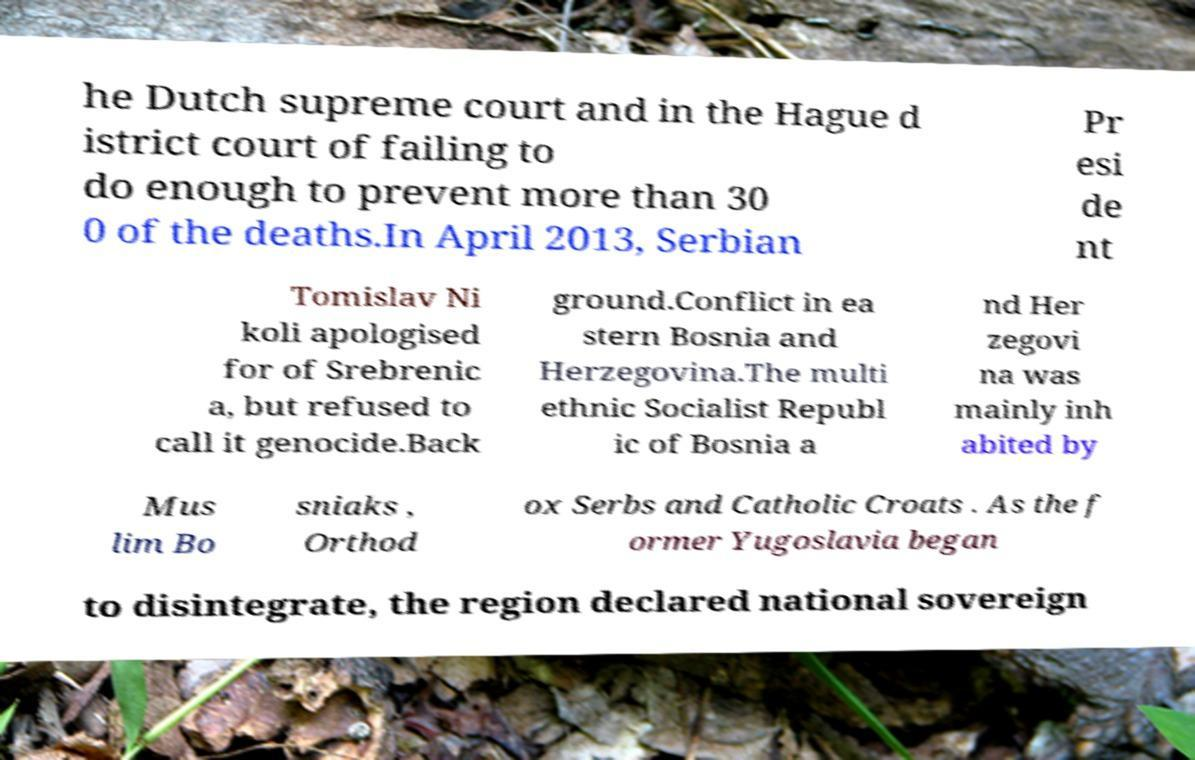Can you read and provide the text displayed in the image?This photo seems to have some interesting text. Can you extract and type it out for me? he Dutch supreme court and in the Hague d istrict court of failing to do enough to prevent more than 30 0 of the deaths.In April 2013, Serbian Pr esi de nt Tomislav Ni koli apologised for of Srebrenic a, but refused to call it genocide.Back ground.Conflict in ea stern Bosnia and Herzegovina.The multi ethnic Socialist Republ ic of Bosnia a nd Her zegovi na was mainly inh abited by Mus lim Bo sniaks , Orthod ox Serbs and Catholic Croats . As the f ormer Yugoslavia began to disintegrate, the region declared national sovereign 